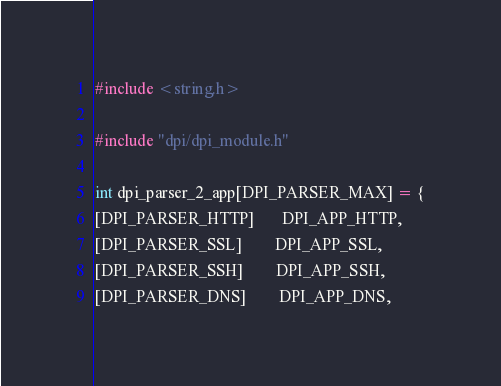Convert code to text. <code><loc_0><loc_0><loc_500><loc_500><_C_>#include <string.h>

#include "dpi/dpi_module.h"

int dpi_parser_2_app[DPI_PARSER_MAX] = {
[DPI_PARSER_HTTP]       DPI_APP_HTTP,
[DPI_PARSER_SSL]        DPI_APP_SSL,
[DPI_PARSER_SSH]        DPI_APP_SSH,
[DPI_PARSER_DNS]        DPI_APP_DNS,</code> 